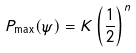Convert formula to latex. <formula><loc_0><loc_0><loc_500><loc_500>P _ { \max } ( \psi ) = K \left ( \frac { 1 } { 2 } \right ) ^ { n }</formula> 